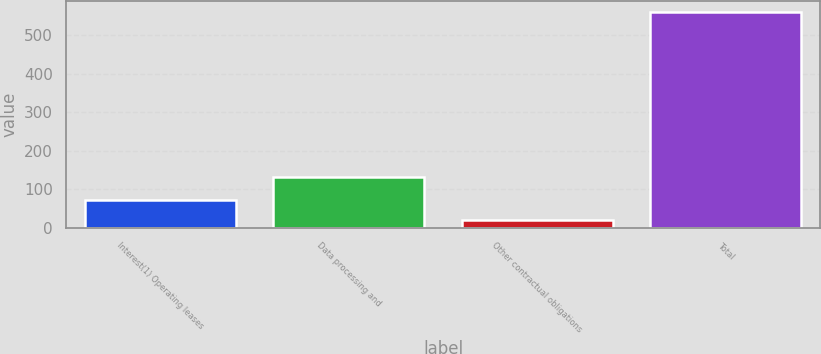Convert chart to OTSL. <chart><loc_0><loc_0><loc_500><loc_500><bar_chart><fcel>Interest(1) Operating leases<fcel>Data processing and<fcel>Other contractual obligations<fcel>Total<nl><fcel>72.9<fcel>131.7<fcel>18.8<fcel>559.8<nl></chart> 